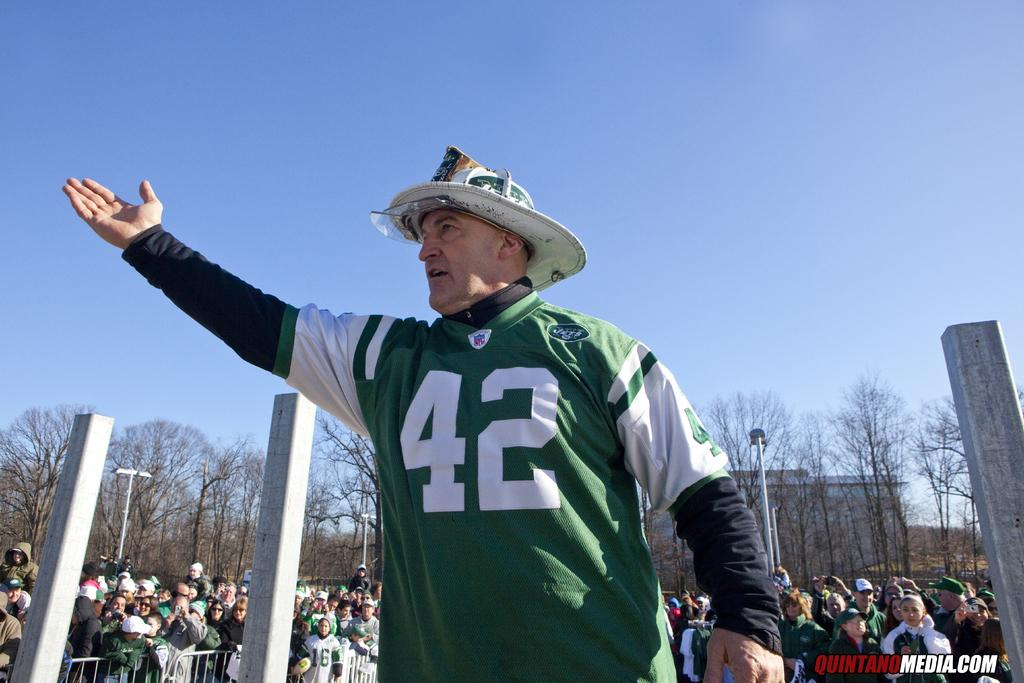<image>
Write a terse but informative summary of the picture. Man with his arm in the air in front of people with quintanomedia.com in lower right corner. with 